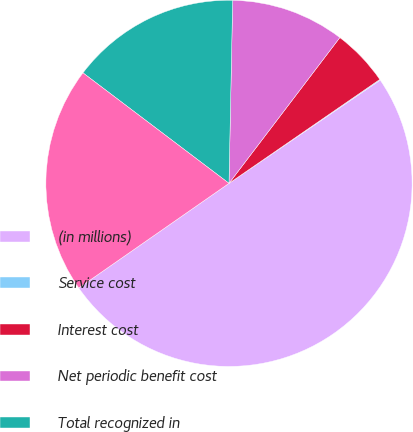<chart> <loc_0><loc_0><loc_500><loc_500><pie_chart><fcel>(in millions)<fcel>Service cost<fcel>Interest cost<fcel>Net periodic benefit cost<fcel>Total recognized in<fcel>Total recognized in net<nl><fcel>49.85%<fcel>0.07%<fcel>5.05%<fcel>10.03%<fcel>15.01%<fcel>19.99%<nl></chart> 